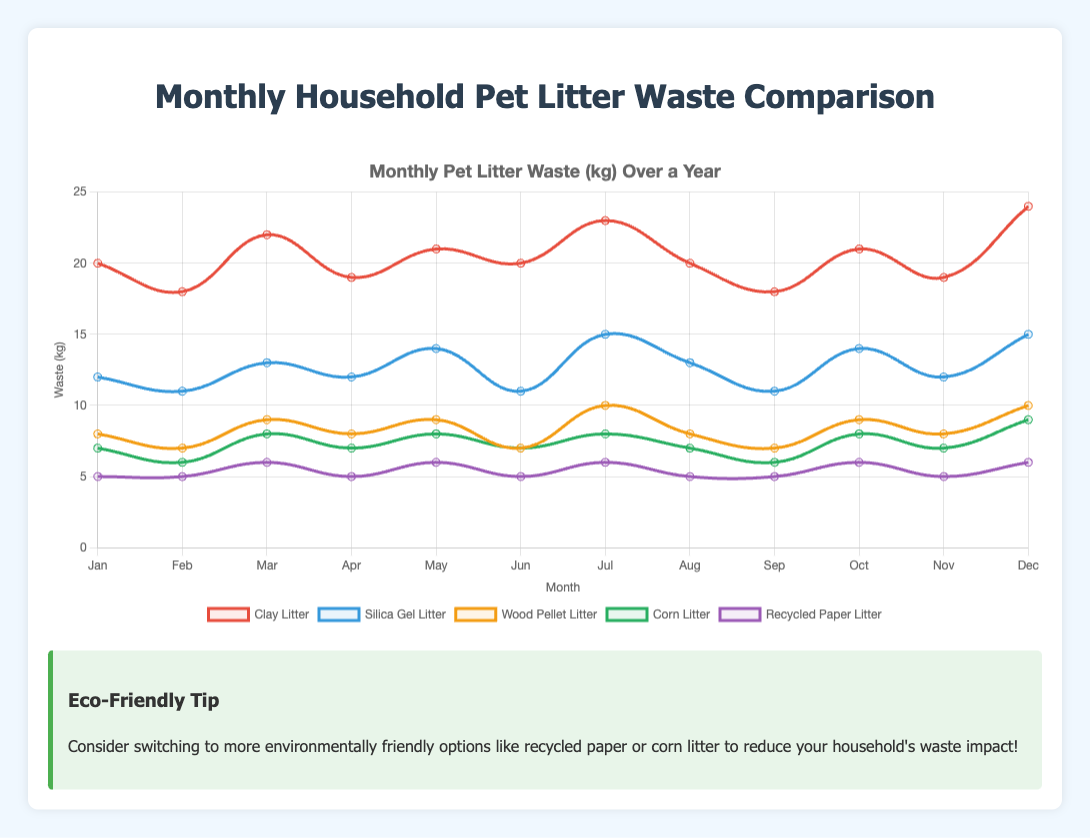What is the total household waste generated by clay litter in the first quarter of the year? To find the total household waste generated by clay litter in the first quarter (Jan-Mar), add the waste amounts for January (20 kg), February (18 kg), and March (22 kg). 20 + 18 + 22 = 60 kg
Answer: 60 kg Which month shows the highest waste generation for silica gel litter? Look at the silica gel litter data for each month and identify the highest value. The highest waste generation is in July and December, both with 15 kg.
Answer: July and December How much more waste does clay litter generate compared to corn litter in March? Subtract the corn litter waste for March (8 kg) from the clay litter waste for March (22 kg). 22 - 8 = 14 kg
Answer: 14 kg What is the average monthly waste generated by recycled paper litter? Add up the monthly recycled paper litter waste (5, 5, 6, 5, 6, 5, 6, 5, 5, 6, 5, 6), and divide by the number of months (12). (5 + 5 + 6 + 5 + 6 + 5 + 6 + 5 + 5 + 6 + 5 + 6) / 12 = 5.42 kg
Answer: 5.42 kg Compare the total monthly waste of wood pellet litter and corn litter. Which one is greater in May? Look at the May values for wood pellet litter (9 kg) and corn litter (8 kg). Compare them. 9 kg (wood pellet) is greater than 8 kg (corn)
Answer: Wood pellet litter Which litter type consistently generates the least amount of waste each month? Examine the dataset and identify which litter type has the lowest values month over month. Recycled paper litter consistently has the lowest values.
Answer: Recycled paper litter What is the difference in waste generated between clay litter and silica gel litter in November? Subtract the silica gel litter waste for November (12 kg) from the clay litter waste for November (19 kg). 19 - 12 = 7 kg
Answer: 7 kg What is the trend in household waste generated by wood pellet litter from January to December? Analyze the data points for wood pellet litter from January (8 kg) to December (10 kg). The waste amount generally increases from January to December with some fluctuations.
Answer: Increasing trend What color is the line representing corn litter in the chart? Refer to the visual attributes provided; the line for corn litter is green.
Answer: Green Is the waste generated by any litter type ever equal to 10 kg, and if so, which month and type? Scan through the dataset to find any instances of 10 kg. Wood pellet litter in July and December, and silica gel in July achieve 10 kg waste generation.
Answer: July (Wood Pellet Litter), December (Wood Pellet Litter and Silica Gel Litter) 